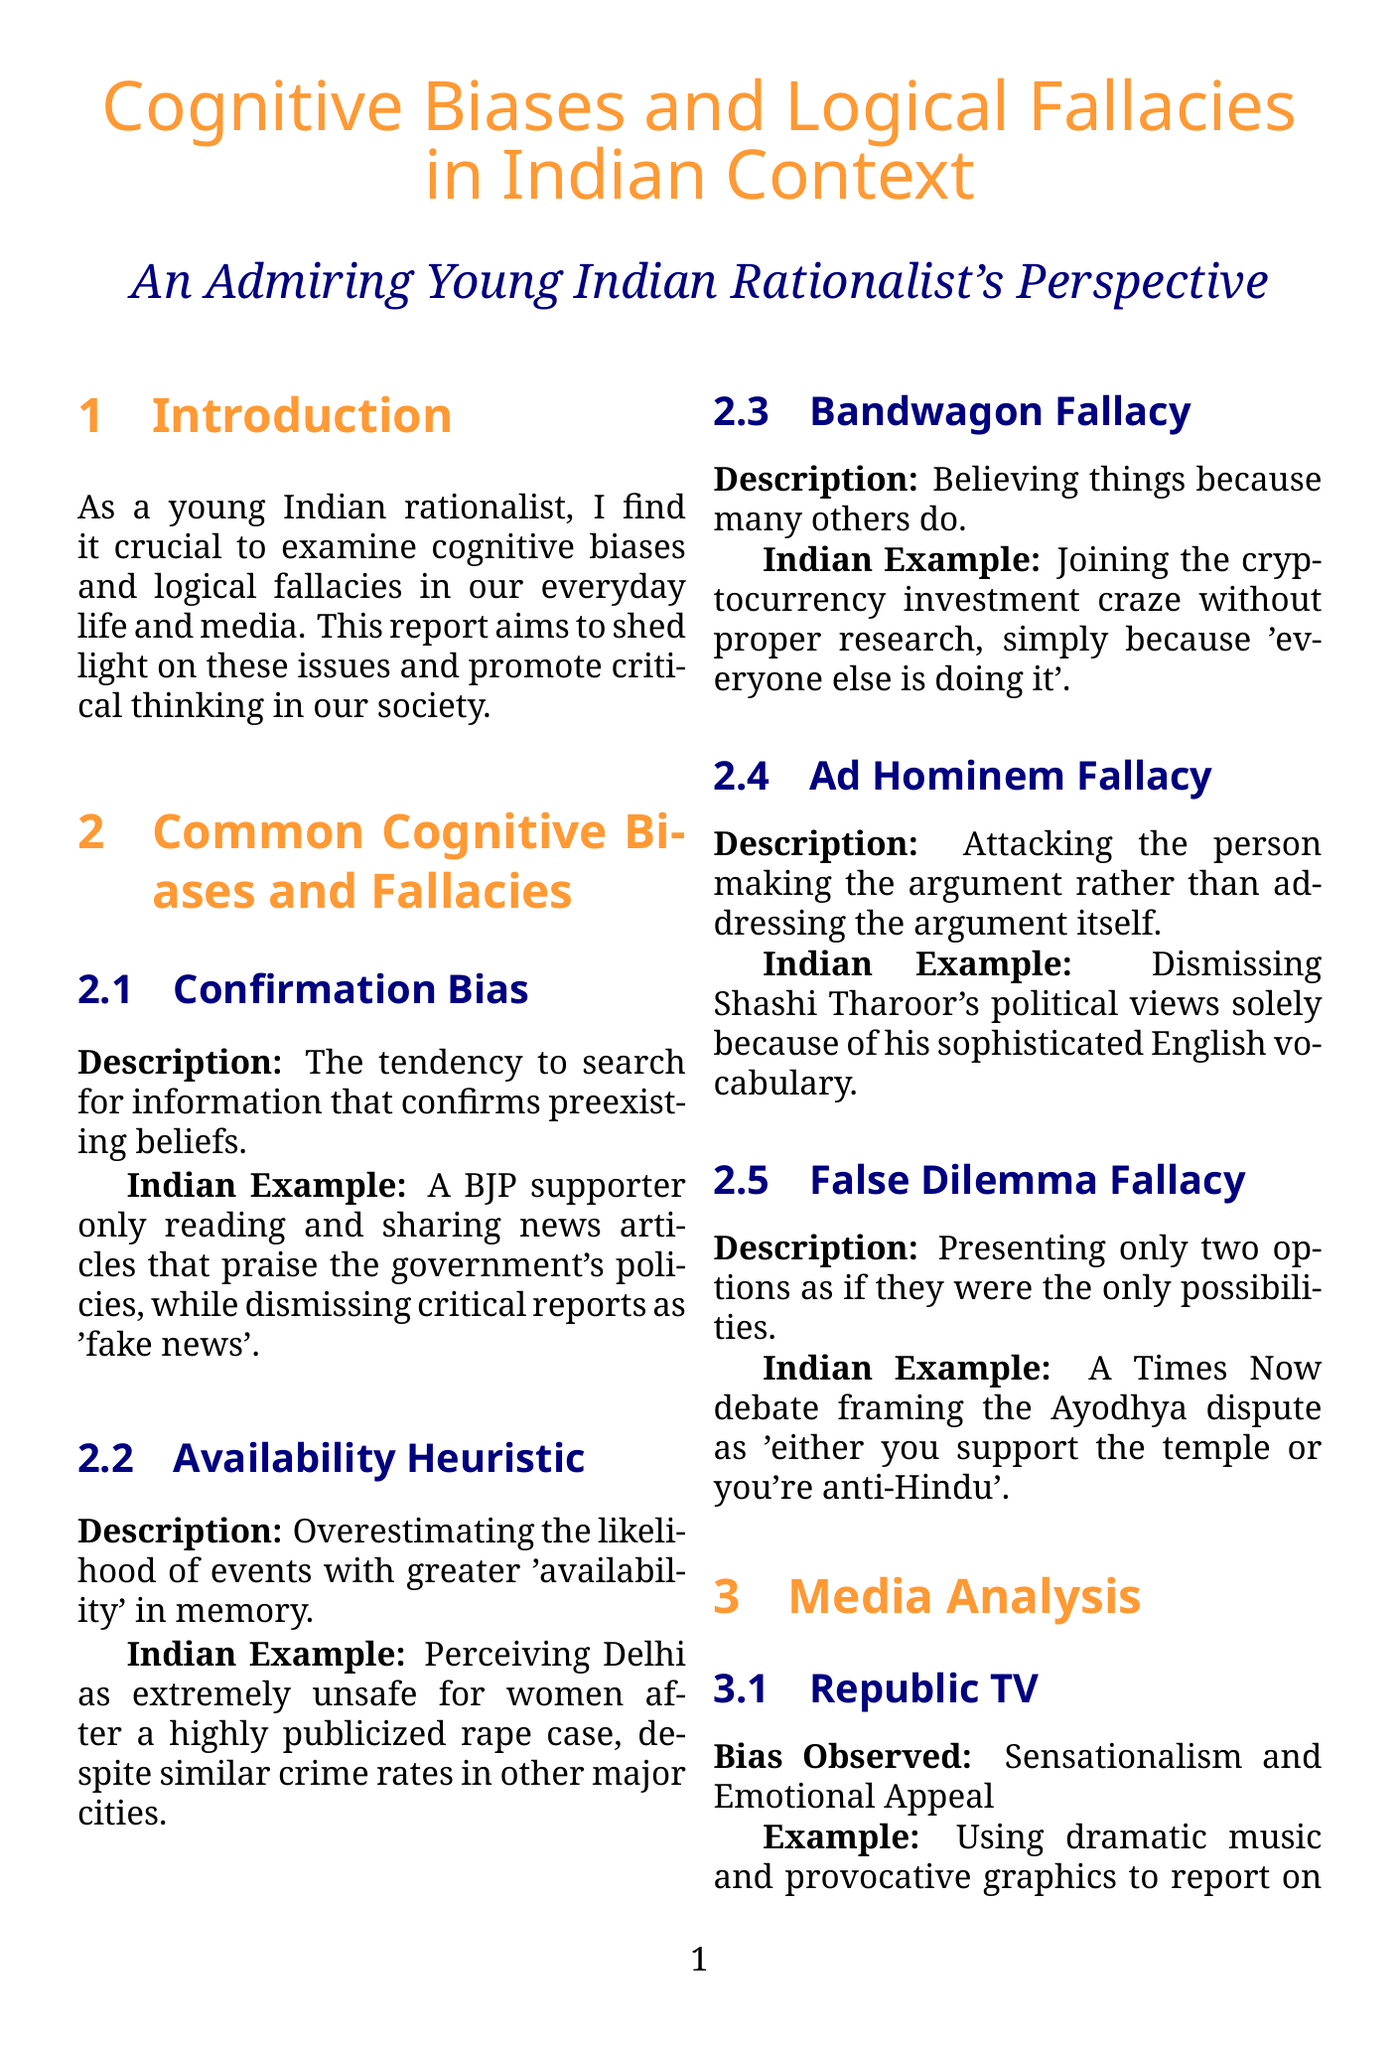What is the cognitive bias related to preferring information that confirms existing beliefs? This question seeks to identify a specific cognitive bias discussed in the document.
Answer: Confirmation Bias What is an Indian example of the Availability Heuristic? This question looks for a specific everyday Indian scenario illustrating a cognitive bias.
Answer: Perceiving Delhi as extremely unsafe for women after a highly publicized rape case Which media source is associated with sensationalism and emotional appeal? This question aims to find a specific media outlet mentioned in the report.
Answer: Republic TV Who founded the Indian Rationalist Association? This question targets identifying a prominent figure in the rationalist movement within India.
Answer: Sanal Edamaruku What is one challenge faced by young Indian rationalists? This question is designed to uncover a critical challenge mentioned in the document affecting rationalists.
Answer: Social pressure to conform to traditional beliefs What type of fallacy involves attacking the person instead of the argument? This question aims to pinpoint a specific logical fallacy discussed in the report.
Answer: Ad Hominem Fallacy What critical thinking strategy involves checking information with reliable sources? This question looks for a specific strategy recommended for improving critical thinking.
Answer: Fact-checking Which organization focuses on popularizing science among students in India? This question seeks to find a specific organization mentioned that encourages science education.
Answer: Breakthrough Science Society What is the example given for the False Dilemma Fallacy? This question requires recalling an Indian example of a specific logical fallacy presented.
Answer: A Times Now debate framing the Ayodhya dispute as 'either you support the temple or you're anti-Hindu' What online community promotes free thought and secularism in India? This question seeks to identify a specific rationalist movement available online in the document.
Answer: Nirmukta 